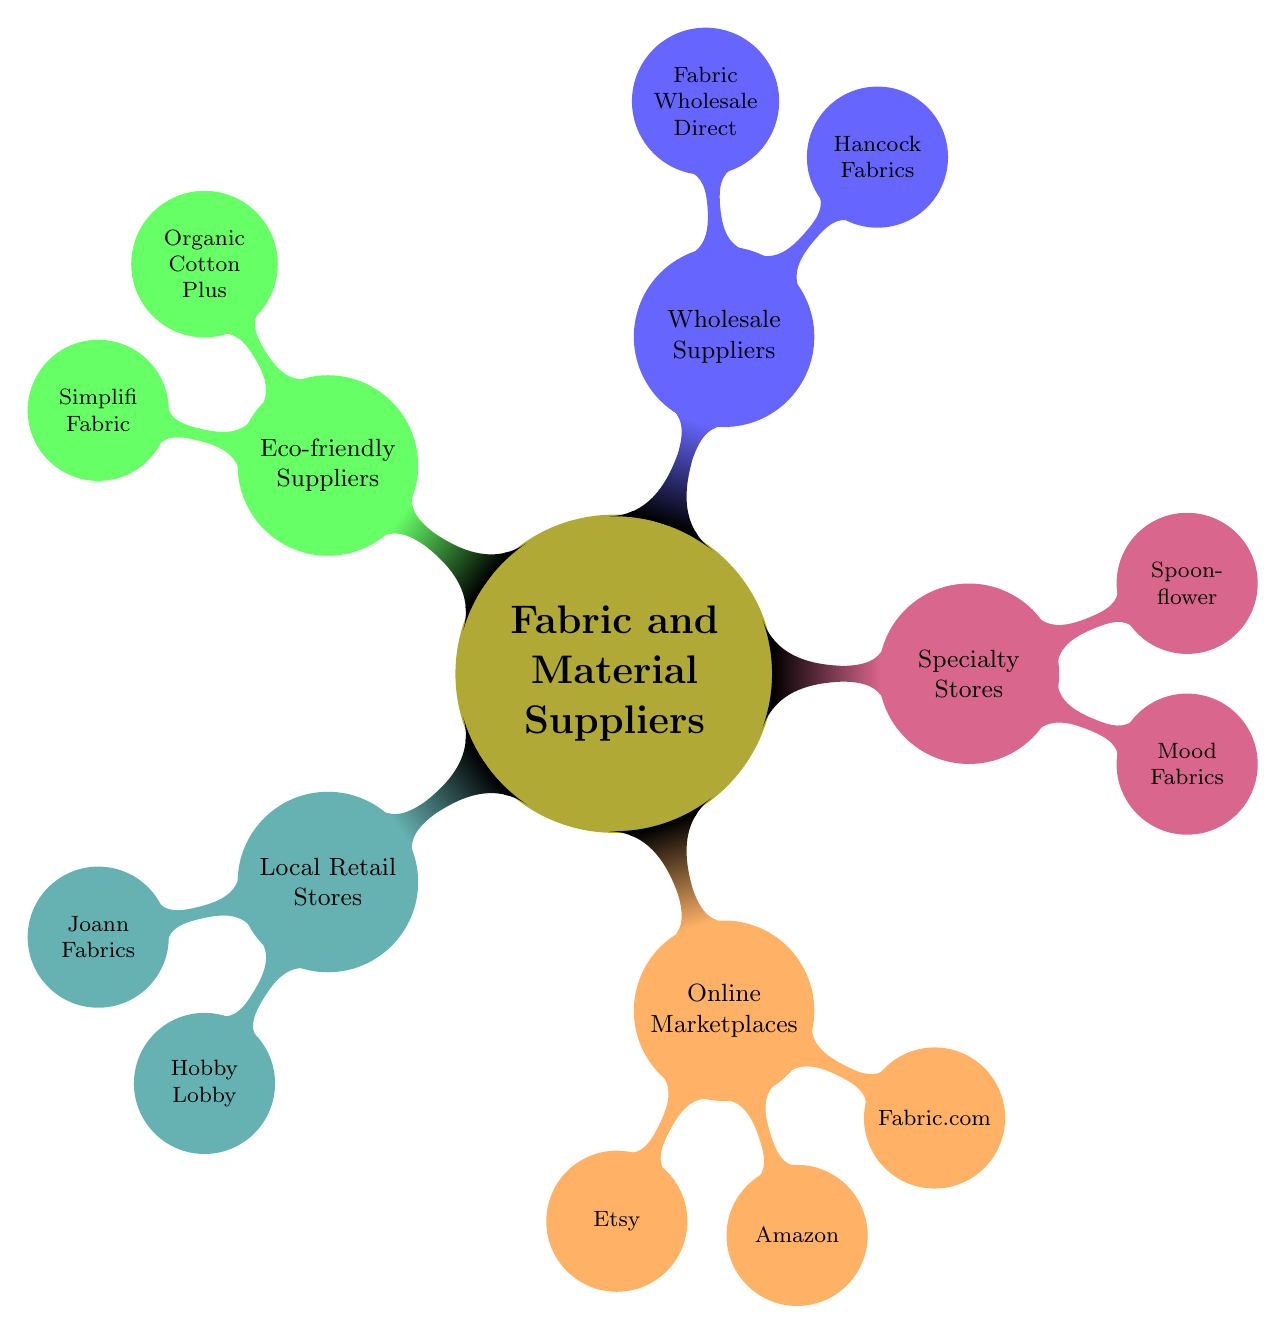What are the local retail stores listed? The diagram shows two local retail stores under the "Local Retail Stores" node, which are "Joann Fabrics" and "Hobby Lobby".
Answer: Joann Fabrics, Hobby Lobby How many online marketplaces are shown in the diagram? The "Online Marketplaces" node contains three suppliers: "Etsy", "Amazon", and "Fabric.com". Therefore, there are three online marketplaces listed.
Answer: 3 Which type of supplier includes Mood Fabrics? "Mood Fabrics" is located under the "Specialty Stores" node, indicating that it falls under this category of suppliers.
Answer: Specialty Stores How many eco-friendly suppliers are mentioned? The "Eco-friendly Suppliers" node contains two suppliers: "Organic Cotton Plus" and "Simplifi Fabric". Therefore, there are two eco-friendly suppliers mentioned.
Answer: 2 Which category has the most suppliers listed? The "Online Marketplaces" category has three suppliers – "Etsy", "Amazon", and "Fabric.com". This is more than any other category, making it the one with the most suppliers.
Answer: Online Marketplaces What is the relationship between wholesale suppliers and specialty stores in the diagram? Both "Wholesale Suppliers" and "Specialty Stores" are children nodes of the main node "Fabric and Material Suppliers". This indicates they are both types of suppliers categorized under the main topic without any direct link between them.
Answer: No direct relationship Name one eco-friendly supplier. Under the "Eco-friendly Suppliers" node, two suppliers are listed. One of them is "Organic Cotton Plus".
Answer: Organic Cotton Plus How many types of suppliers are represented in the diagram? The main node "Fabric and Material Suppliers" has five child nodes: "Local Retail Stores", "Online Marketplaces", "Specialty Stores", "Wholesale Suppliers", and "Eco-friendly Suppliers". This totals to five types of suppliers represented.
Answer: 5 